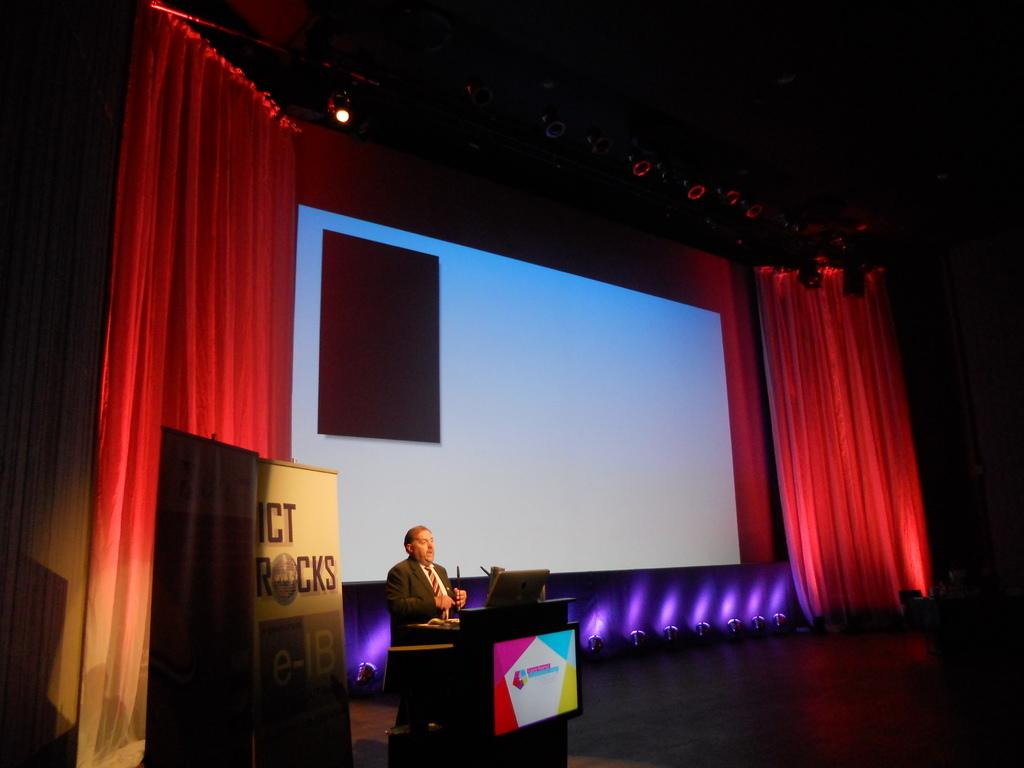What is the person in the image doing? The person is standing in front of the podium. What electronic device is on the stage? There is a laptop on the stage. What is displayed on the laptop? There are objects on the laptop. What is used for displaying visuals on the stage? There is a large screen on the stage. What type of curtains are on the stage? There are red curtains on the stage. What is used for writing or displaying information on the stage? There are whiteboards on the stage. What is used for illumination on the stage? There are lights on the stage. How many units of the bike can be seen in the image? There is no bike present in the image. 